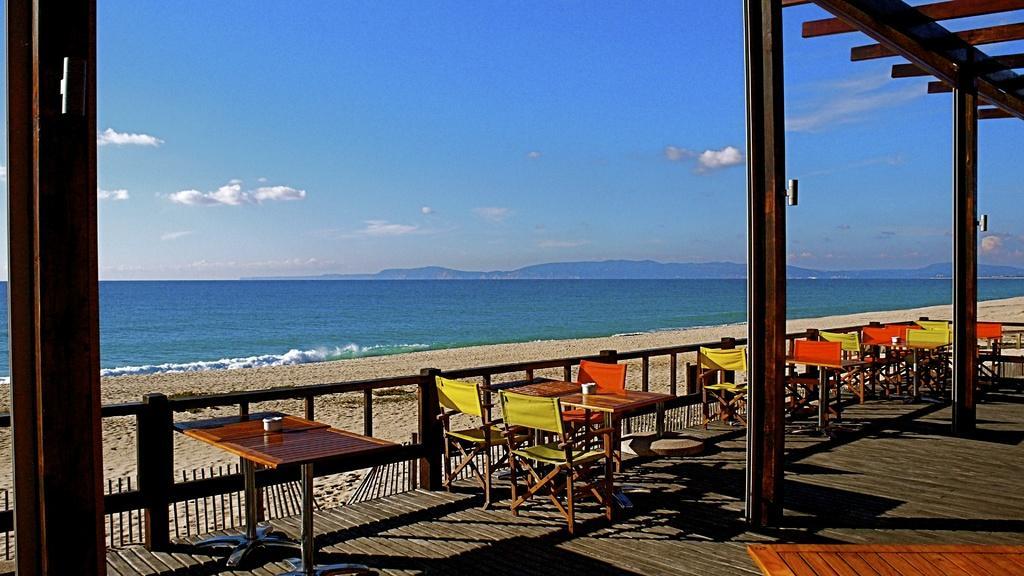How would you summarize this image in a sentence or two? In this picture I can see the platform in front on which there are many tables and chairs and I see few poles and I can also see the railing. In the background I can see the sand, water and the sky. 